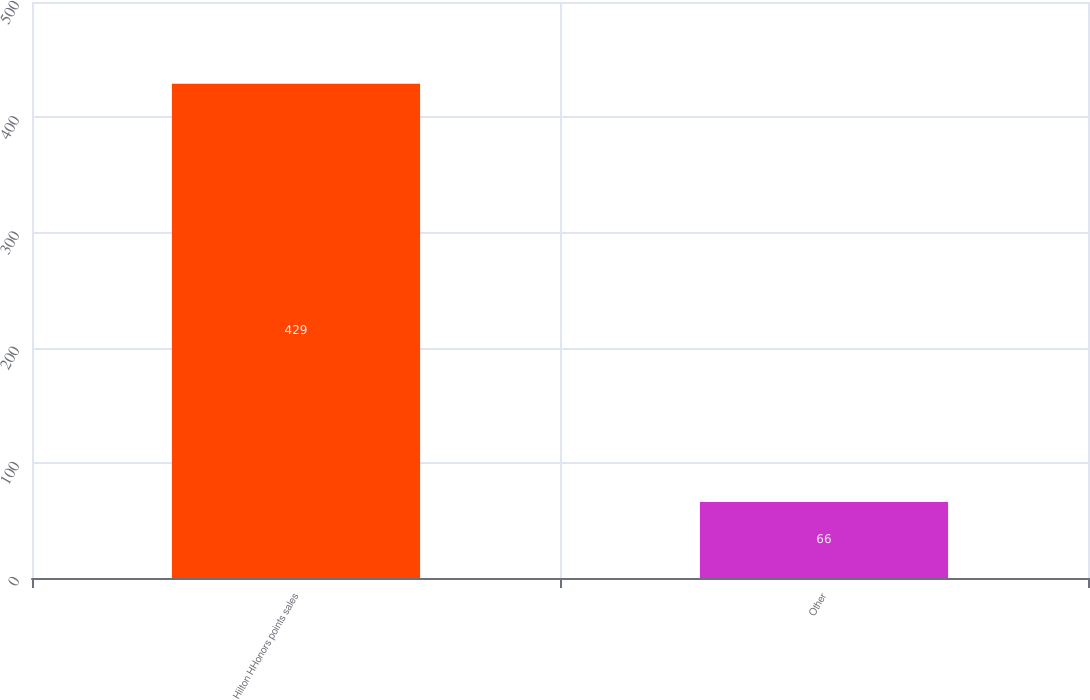Convert chart. <chart><loc_0><loc_0><loc_500><loc_500><bar_chart><fcel>Hilton HHonors points sales<fcel>Other<nl><fcel>429<fcel>66<nl></chart> 